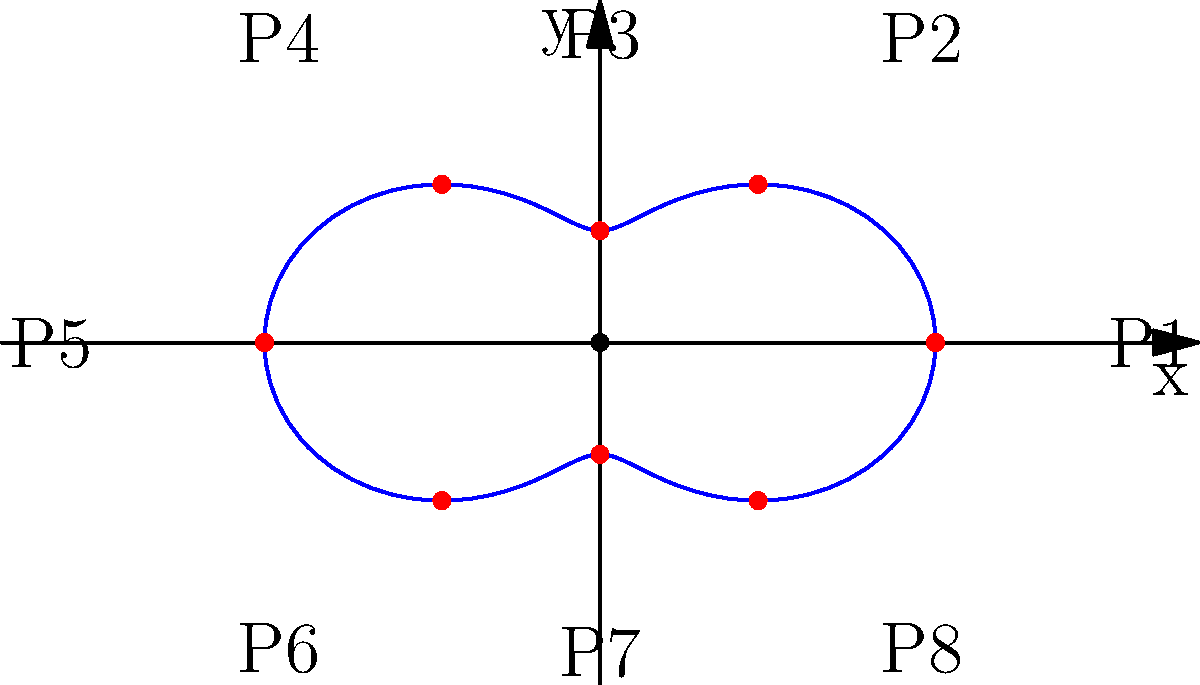The polar graph above represents the rotation speed of a circular conveyor belt at different points. The equation of the graph is $r = 2 + \cos(2\theta)$. At which point(s) is the rotation speed of the conveyor belt at its maximum? To find the points of maximum rotation speed, we need to follow these steps:

1) The rotation speed is inversely proportional to the distance from the center. So, we're looking for the point(s) closest to the origin.

2) The distance from the origin is given by the radius $r$ in the polar equation.

3) The equation is $r = 2 + \cos(2\theta)$. The minimum value of $r$ occurs when $\cos(2\theta)$ is at its minimum.

4) The cosine function has a minimum value of -1, which occurs when its argument is an odd multiple of $\pi$.

5) So, we need to solve: $2\theta = \pi, 3\pi, 5\pi, ...$

6) This gives us $\theta = \frac{\pi}{2}, \frac{3\pi}{2}, \frac{5\pi}{2}, ...$

7) In the given graph, these correspond to points P3 and P7, which are located on the y-axis.

8) At these points, $r = 2 + \cos(\pi) = 2 - 1 = 1$, which is indeed the minimum distance from the origin.

Therefore, the rotation speed of the conveyor belt is at its maximum at points P3 and P7.
Answer: P3 and P7 